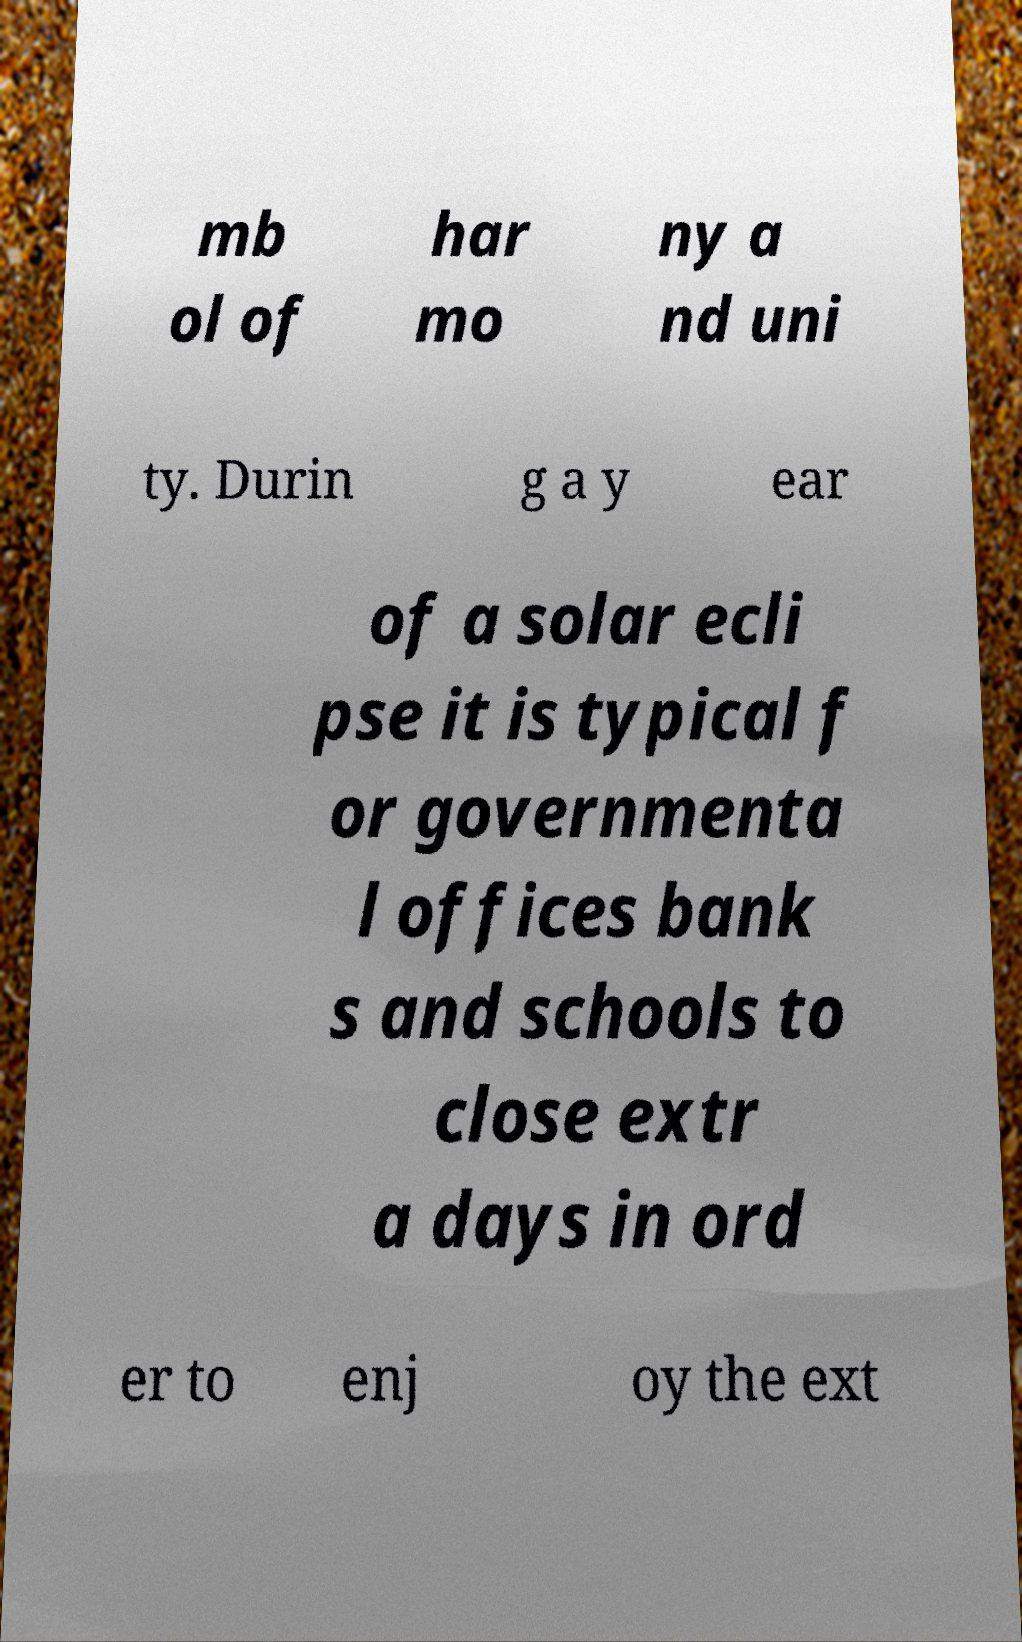What messages or text are displayed in this image? I need them in a readable, typed format. mb ol of har mo ny a nd uni ty. Durin g a y ear of a solar ecli pse it is typical f or governmenta l offices bank s and schools to close extr a days in ord er to enj oy the ext 